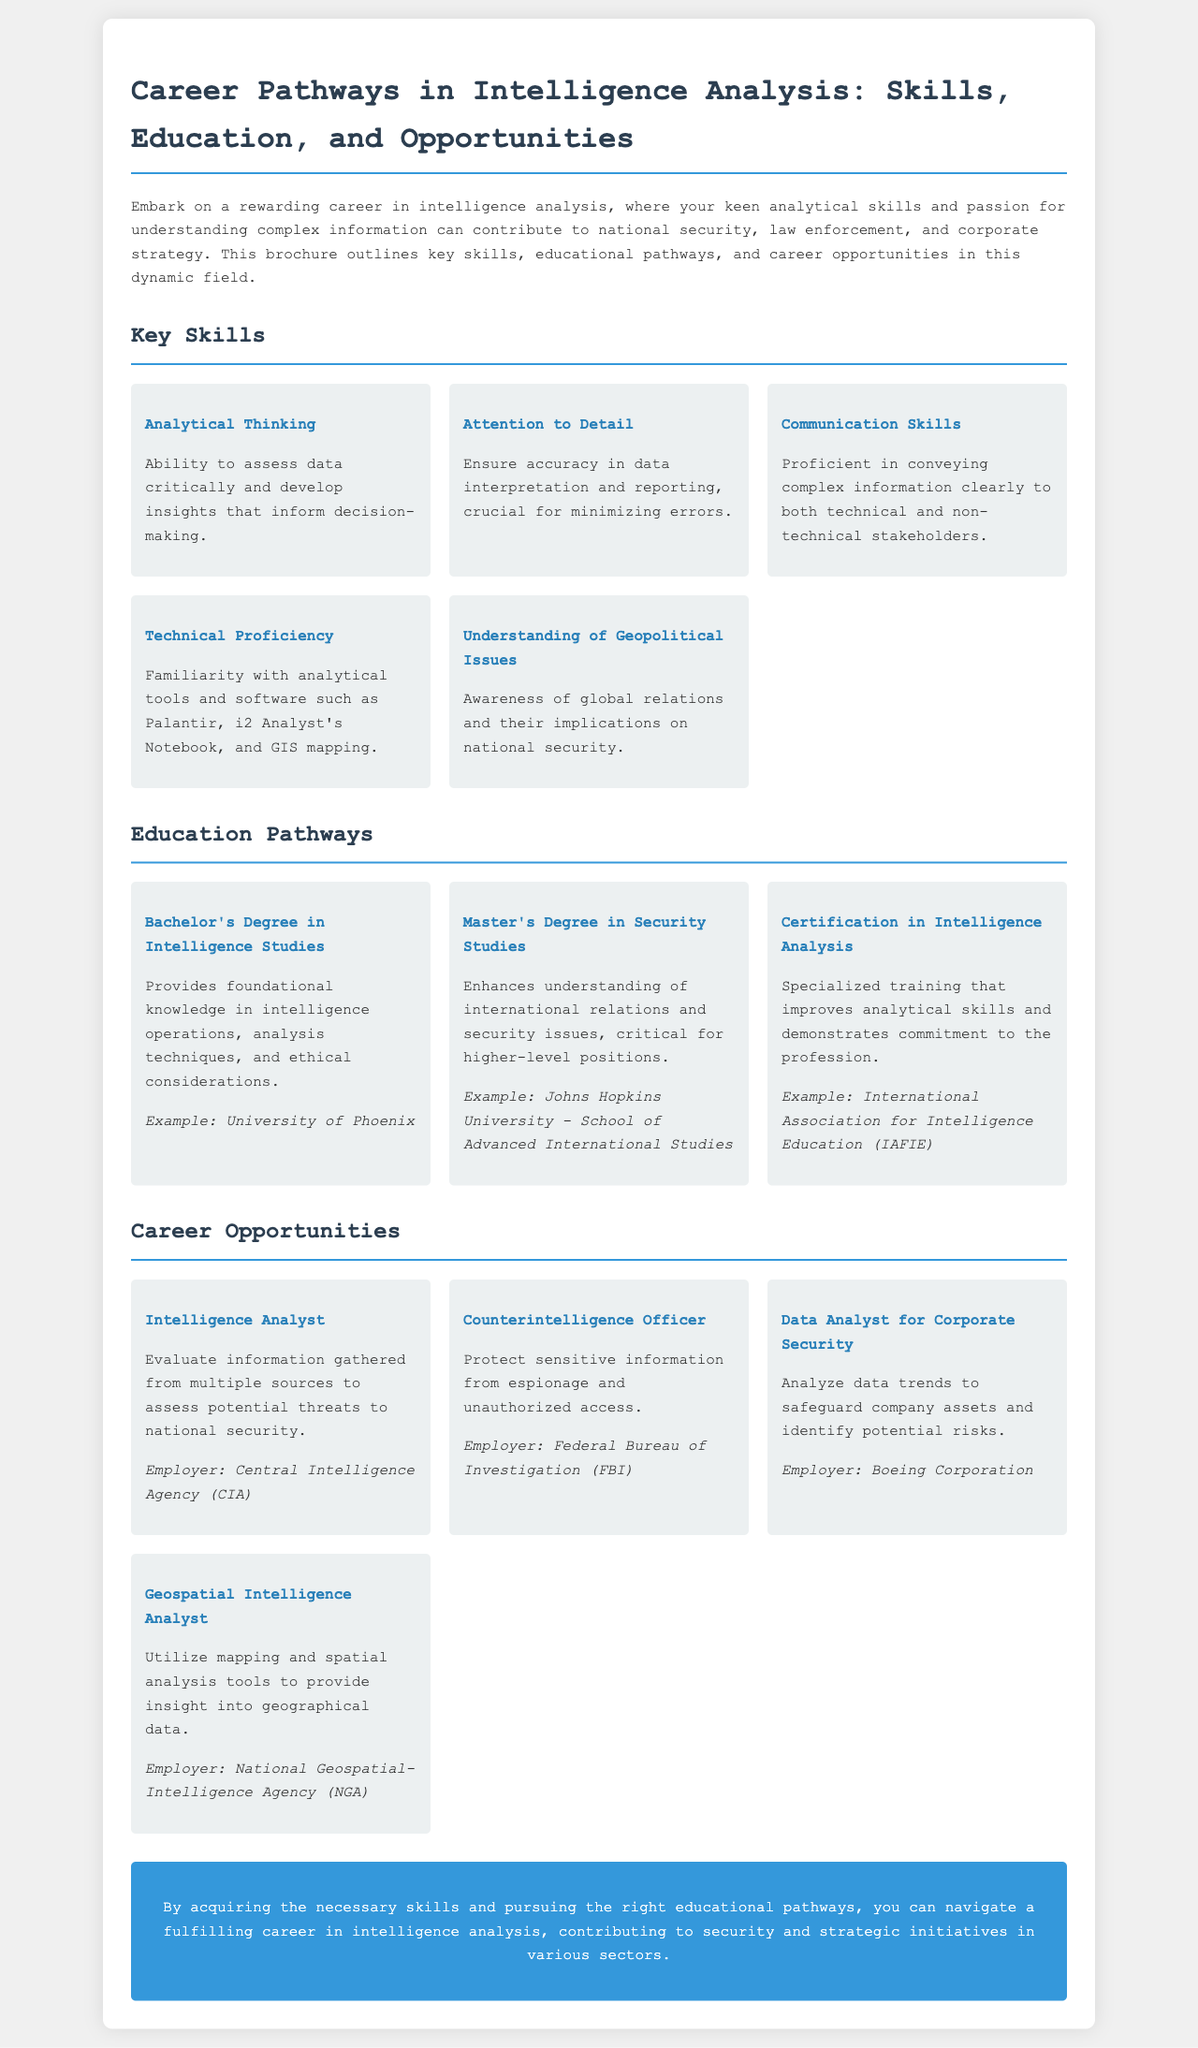What is the title of the brochure? The title of the brochure is prominently displayed at the top of the document.
Answer: Career Pathways in Intelligence Analysis: Skills, Education, and Opportunities What university offers a Bachelor's Degree in Intelligence Studies? The document provides an example of an institution that offers this degree.
Answer: University of Phoenix What key skill involves the ability to assess data critically? The brochure lists key skills necessary for intelligence analysis.
Answer: Analytical Thinking Who is an employer for a Data Analyst for Corporate Security? The document mentions an employer associated with this specific role in intelligence analysis.
Answer: Boeing Corporation What type of degree enhances understanding of security issues? The explanation of this educational pathway indicates its benefits clearly.
Answer: Master's Degree in Security Studies What skill is necessary for minimizing errors in data reporting? The brochure highlights important skills required in the intelligence analysis field.
Answer: Attention to Detail Which role evaluates information to assess potential threats to national security? The document lists multiple roles in intelligence analysis with their descriptions.
Answer: Intelligence Analyst What organization provides certification in Intelligence Analysis? The example provided highlights an organization that offers specialized training.
Answer: International Association for Intelligence Education (IAFIE) How many key skills are listed in the brochure? The section on key skills in the document enumerates the skills clearly.
Answer: Five 